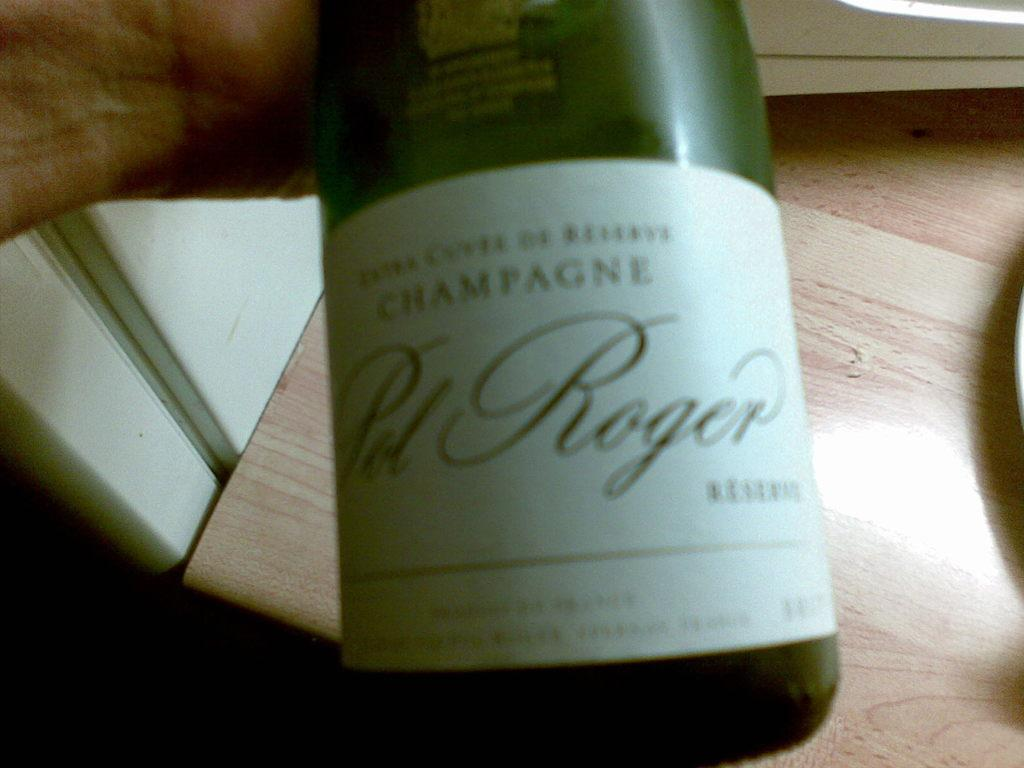<image>
Relay a brief, clear account of the picture shown. A bottle of "CHAMPAGNE" is on the table. 